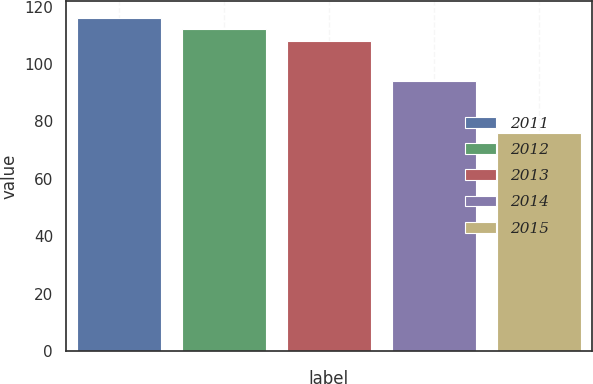Convert chart to OTSL. <chart><loc_0><loc_0><loc_500><loc_500><bar_chart><fcel>2011<fcel>2012<fcel>2013<fcel>2014<fcel>2015<nl><fcel>116<fcel>112<fcel>108<fcel>94<fcel>76<nl></chart> 